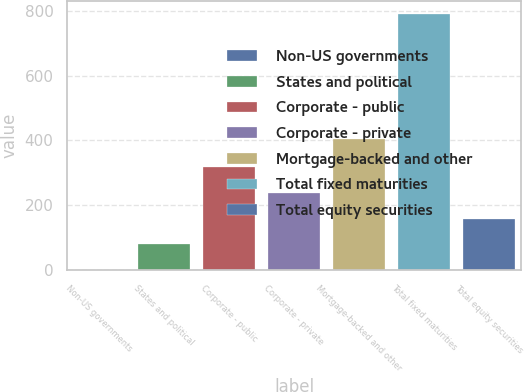Convert chart. <chart><loc_0><loc_0><loc_500><loc_500><bar_chart><fcel>Non-US governments<fcel>States and political<fcel>Corporate - public<fcel>Corporate - private<fcel>Mortgage-backed and other<fcel>Total fixed maturities<fcel>Total equity securities<nl><fcel>1.1<fcel>80.05<fcel>316.9<fcel>237.95<fcel>405.1<fcel>790.6<fcel>159<nl></chart> 